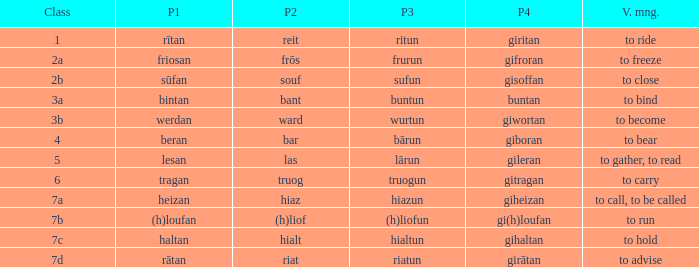What is the verb meaning of the word with part 3 "sufun"? To close. 